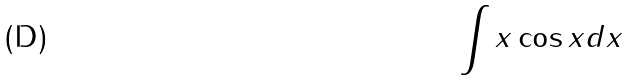<formula> <loc_0><loc_0><loc_500><loc_500>\int x \cos x d x</formula> 